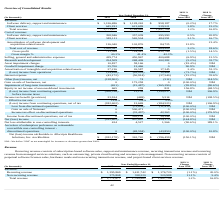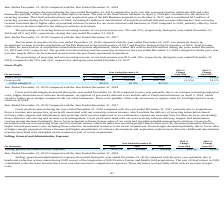According to Allscripts Healthcare Solutions's financial document, What is the recurring revenue in 2019? According to the financial document, $1,395,869 (in thousands). The relevant text states: "Recurring revenue $ 1,395,869 $ 1,411,742 $ 1,176,720 (1.1%) 20.0%..." Also, What is the recurring revenue in 2018? According to the financial document, $1,411,742 (in thousands). The relevant text states: "Recurring revenue $ 1,395,869 $ 1,411,742 $ 1,176,720 (1.1%) 20.0%..." Also, What is the recurring revenue in 2017? According to the financial document, $1,176,720 (in thousands). The relevant text states: "Recurring revenue $ 1,395,869 $ 1,411,742 $ 1,176,720 (1.1%) 20.0%..." Also, can you calculate: What was the change in the recurring revenue from 2018 to 2019? Based on the calculation: 1,395,869 - 1,411,742, the result is -15873 (in thousands). This is based on the information: "Recurring revenue $ 1,395,869 $ 1,411,742 $ 1,176,720 (1.1%) 20.0% Recurring revenue $ 1,395,869 $ 1,411,742 $ 1,176,720 (1.1%) 20.0%..." The key data points involved are: 1,395,869, 1,411,742. Also, can you calculate: What is the average Non-recurring revenue between 2017-2019? To answer this question, I need to perform calculations using the financial data. The calculation is: (375,808 + 338,220 + 320,988) / 3, which equals 345005.33 (in thousands). This is based on the information: "Non-recurring revenue 375,808 338,220 320,988 11.1% 5.4% Non-recurring revenue 375,808 338,220 320,988 11.1% 5.4% Non-recurring revenue 375,808 338,220 320,988 11.1% 5.4%..." The key data points involved are: 320,988, 338,220, 375,808. Also, can you calculate: What is the change in the total revenue from 2018 to 2019? Based on the calculation: 1,771,677 - 1,749,962, the result is 21715 (in thousands). This is based on the information: "Total revenue 1,771,677 1,749,962 1,497,708 1.2% 16.8% Total revenue 1,771,677 1,749,962 1,497,708 1.2% 16.8%..." The key data points involved are: 1,749,962, 1,771,677. 